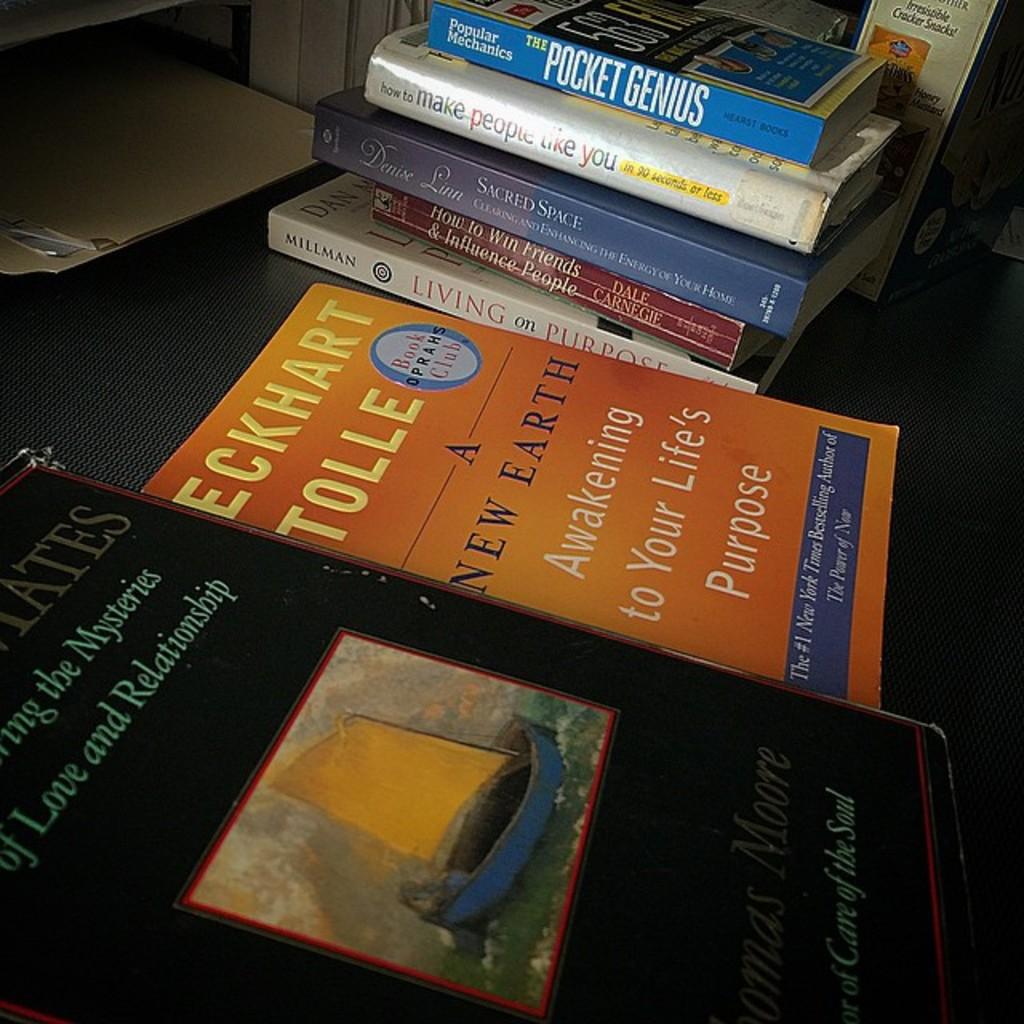Who is the author of the orange book?
Your answer should be compact. Eckhart tolle. 